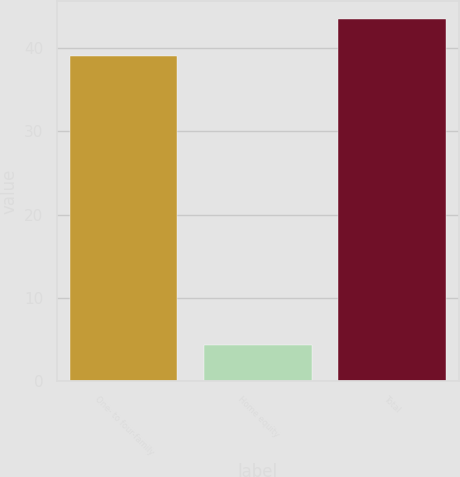<chart> <loc_0><loc_0><loc_500><loc_500><bar_chart><fcel>One- to four-family<fcel>Home equity<fcel>Total<nl><fcel>39<fcel>4.4<fcel>43.4<nl></chart> 